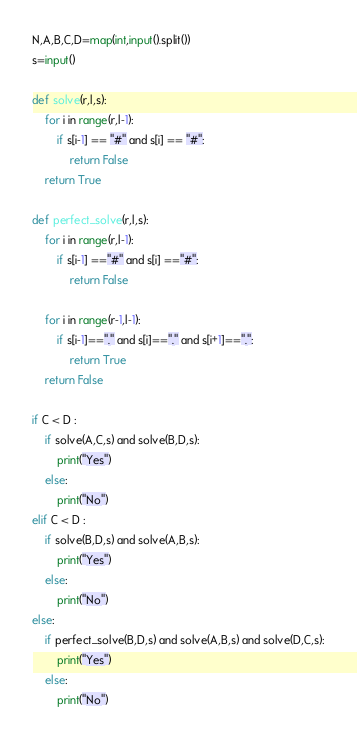Convert code to text. <code><loc_0><loc_0><loc_500><loc_500><_Python_>N,A,B,C,D=map(int,input().split())
s=input()

def solve(r,l,s):
    for i in range(r,l-1):
        if s[i-1] == "#" and s[i] == "#":
            return False
    return True

def perfect_solve(r,l,s):
    for i in range(r,l-1):
        if s[i-1] =="#" and s[i] =="#":
            return False

    for i in range(r-1,l-1):
        if s[i-1]=="." and s[i]=="." and s[i+1]==".":
            return True
    return False

if C < D :
    if solve(A,C,s) and solve(B,D,s):
        print("Yes")
    else:
        print("No")
elif C < D :
    if solve(B,D,s) and solve(A,B,s):
        print("Yes")
    else:
        print("No")
else:
    if perfect_solve(B,D,s) and solve(A,B,s) and solve(D,C,s):
        print("Yes")
    else:
        print("No")</code> 